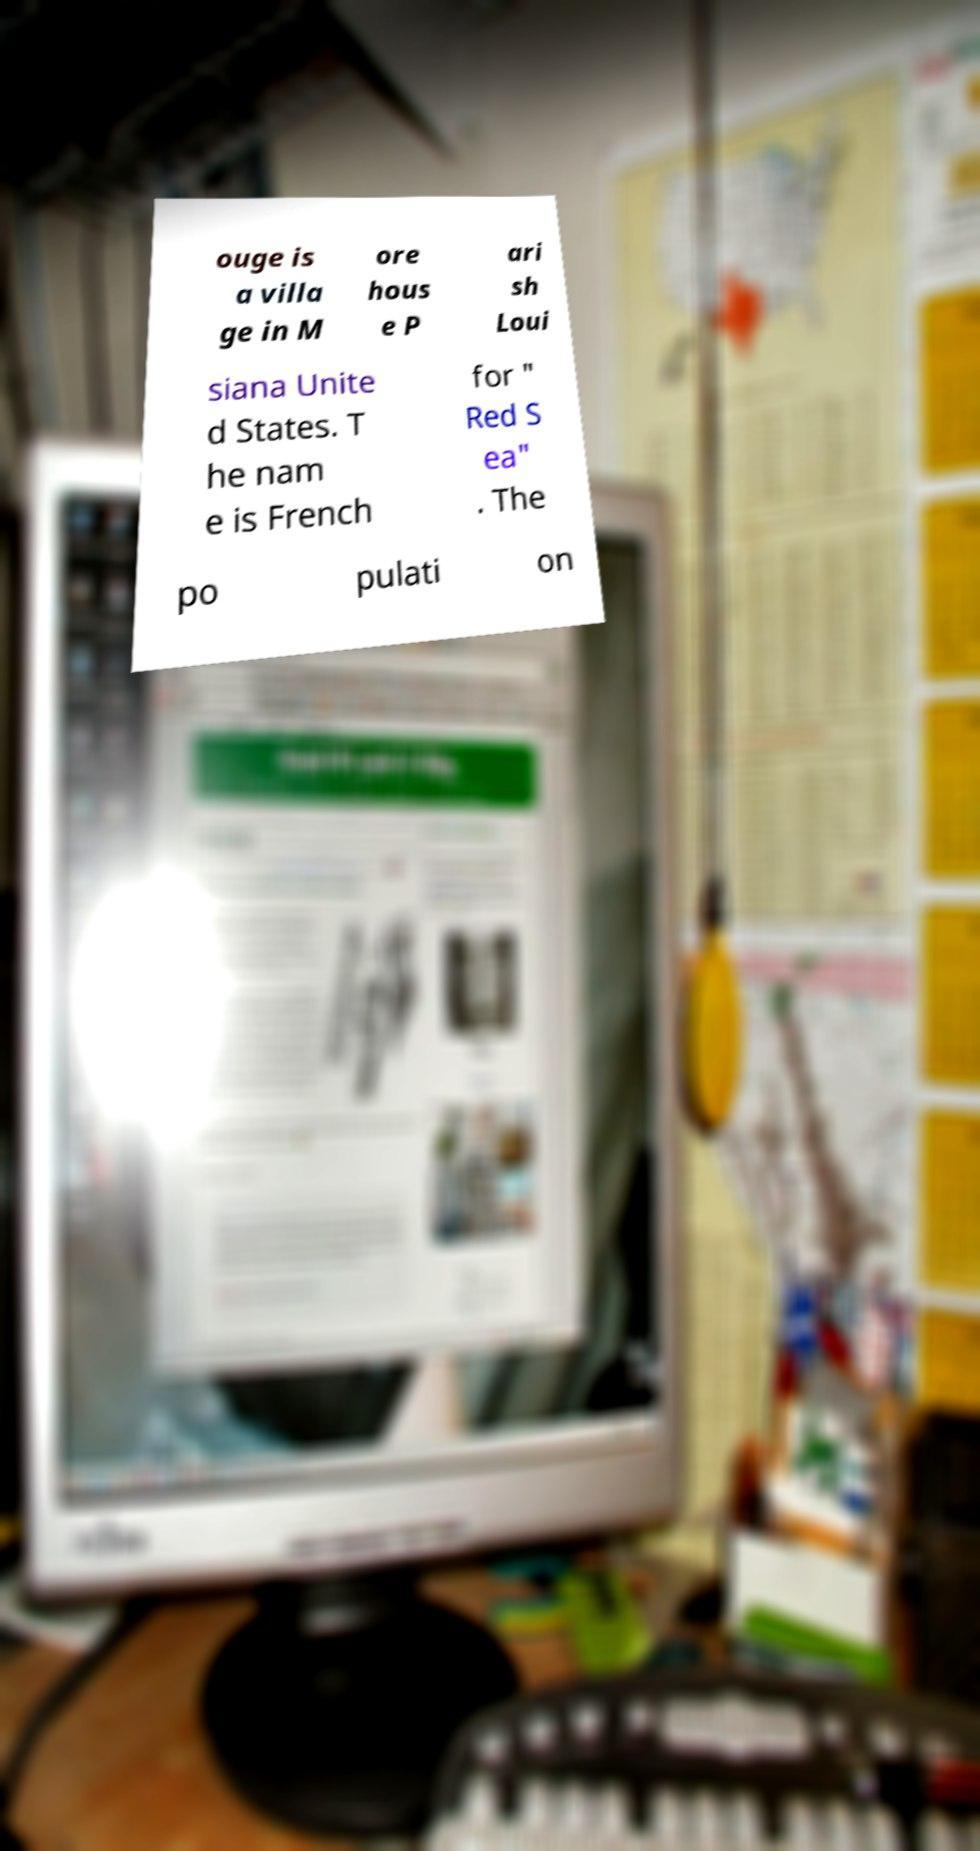For documentation purposes, I need the text within this image transcribed. Could you provide that? ouge is a villa ge in M ore hous e P ari sh Loui siana Unite d States. T he nam e is French for " Red S ea" . The po pulati on 